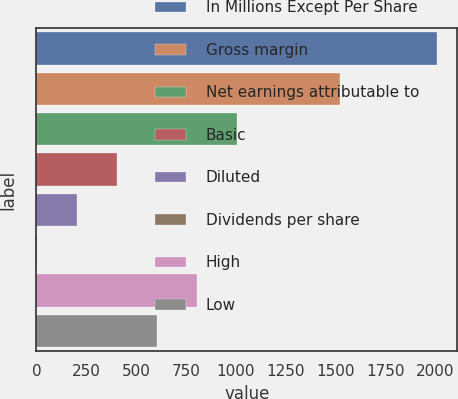Convert chart. <chart><loc_0><loc_0><loc_500><loc_500><bar_chart><fcel>In Millions Except Per Share<fcel>Gross margin<fcel>Net earnings attributable to<fcel>Basic<fcel>Diluted<fcel>Dividends per share<fcel>High<fcel>Low<nl><fcel>2011<fcel>1524.3<fcel>1005.63<fcel>402.42<fcel>201.35<fcel>0.28<fcel>804.56<fcel>603.49<nl></chart> 